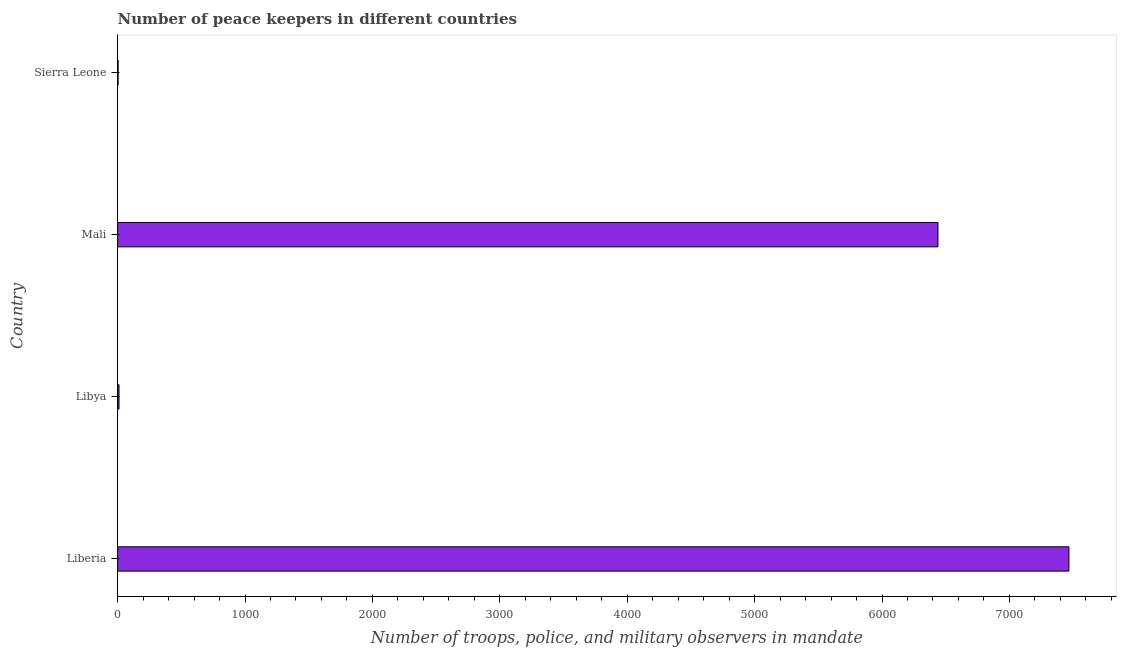Does the graph contain any zero values?
Provide a short and direct response. No. Does the graph contain grids?
Keep it short and to the point. No. What is the title of the graph?
Provide a short and direct response. Number of peace keepers in different countries. What is the label or title of the X-axis?
Give a very brief answer. Number of troops, police, and military observers in mandate. What is the label or title of the Y-axis?
Provide a succinct answer. Country. Across all countries, what is the maximum number of peace keepers?
Your answer should be very brief. 7467. In which country was the number of peace keepers maximum?
Provide a short and direct response. Liberia. In which country was the number of peace keepers minimum?
Give a very brief answer. Sierra Leone. What is the sum of the number of peace keepers?
Provide a succinct answer. 1.39e+04. What is the difference between the number of peace keepers in Liberia and Sierra Leone?
Make the answer very short. 7463. What is the average number of peace keepers per country?
Provide a succinct answer. 3480. What is the median number of peace keepers?
Provide a short and direct response. 3225. What is the ratio of the number of peace keepers in Mali to that in Sierra Leone?
Provide a short and direct response. 1609.75. Is the difference between the number of peace keepers in Liberia and Libya greater than the difference between any two countries?
Keep it short and to the point. No. What is the difference between the highest and the second highest number of peace keepers?
Give a very brief answer. 1028. Is the sum of the number of peace keepers in Liberia and Mali greater than the maximum number of peace keepers across all countries?
Make the answer very short. Yes. What is the difference between the highest and the lowest number of peace keepers?
Keep it short and to the point. 7463. In how many countries, is the number of peace keepers greater than the average number of peace keepers taken over all countries?
Your answer should be compact. 2. How many countries are there in the graph?
Your answer should be compact. 4. What is the difference between two consecutive major ticks on the X-axis?
Give a very brief answer. 1000. Are the values on the major ticks of X-axis written in scientific E-notation?
Keep it short and to the point. No. What is the Number of troops, police, and military observers in mandate of Liberia?
Your answer should be compact. 7467. What is the Number of troops, police, and military observers in mandate in Mali?
Offer a terse response. 6439. What is the Number of troops, police, and military observers in mandate in Sierra Leone?
Provide a succinct answer. 4. What is the difference between the Number of troops, police, and military observers in mandate in Liberia and Libya?
Your answer should be very brief. 7456. What is the difference between the Number of troops, police, and military observers in mandate in Liberia and Mali?
Your answer should be very brief. 1028. What is the difference between the Number of troops, police, and military observers in mandate in Liberia and Sierra Leone?
Your answer should be very brief. 7463. What is the difference between the Number of troops, police, and military observers in mandate in Libya and Mali?
Provide a short and direct response. -6428. What is the difference between the Number of troops, police, and military observers in mandate in Libya and Sierra Leone?
Your answer should be compact. 7. What is the difference between the Number of troops, police, and military observers in mandate in Mali and Sierra Leone?
Make the answer very short. 6435. What is the ratio of the Number of troops, police, and military observers in mandate in Liberia to that in Libya?
Your answer should be very brief. 678.82. What is the ratio of the Number of troops, police, and military observers in mandate in Liberia to that in Mali?
Give a very brief answer. 1.16. What is the ratio of the Number of troops, police, and military observers in mandate in Liberia to that in Sierra Leone?
Your answer should be very brief. 1866.75. What is the ratio of the Number of troops, police, and military observers in mandate in Libya to that in Mali?
Ensure brevity in your answer.  0. What is the ratio of the Number of troops, police, and military observers in mandate in Libya to that in Sierra Leone?
Your response must be concise. 2.75. What is the ratio of the Number of troops, police, and military observers in mandate in Mali to that in Sierra Leone?
Your answer should be very brief. 1609.75. 